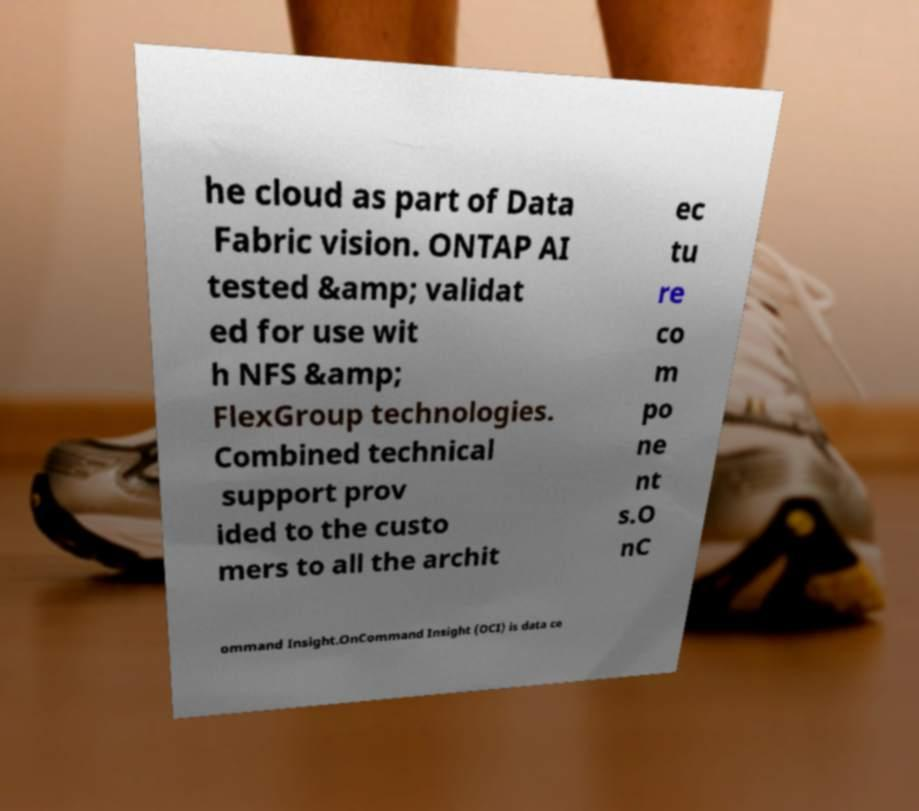There's text embedded in this image that I need extracted. Can you transcribe it verbatim? he cloud as part of Data Fabric vision. ONTAP AI tested &amp; validat ed for use wit h NFS &amp; FlexGroup technologies. Combined technical support prov ided to the custo mers to all the archit ec tu re co m po ne nt s.O nC ommand Insight.OnCommand Insight (OCI) is data ce 